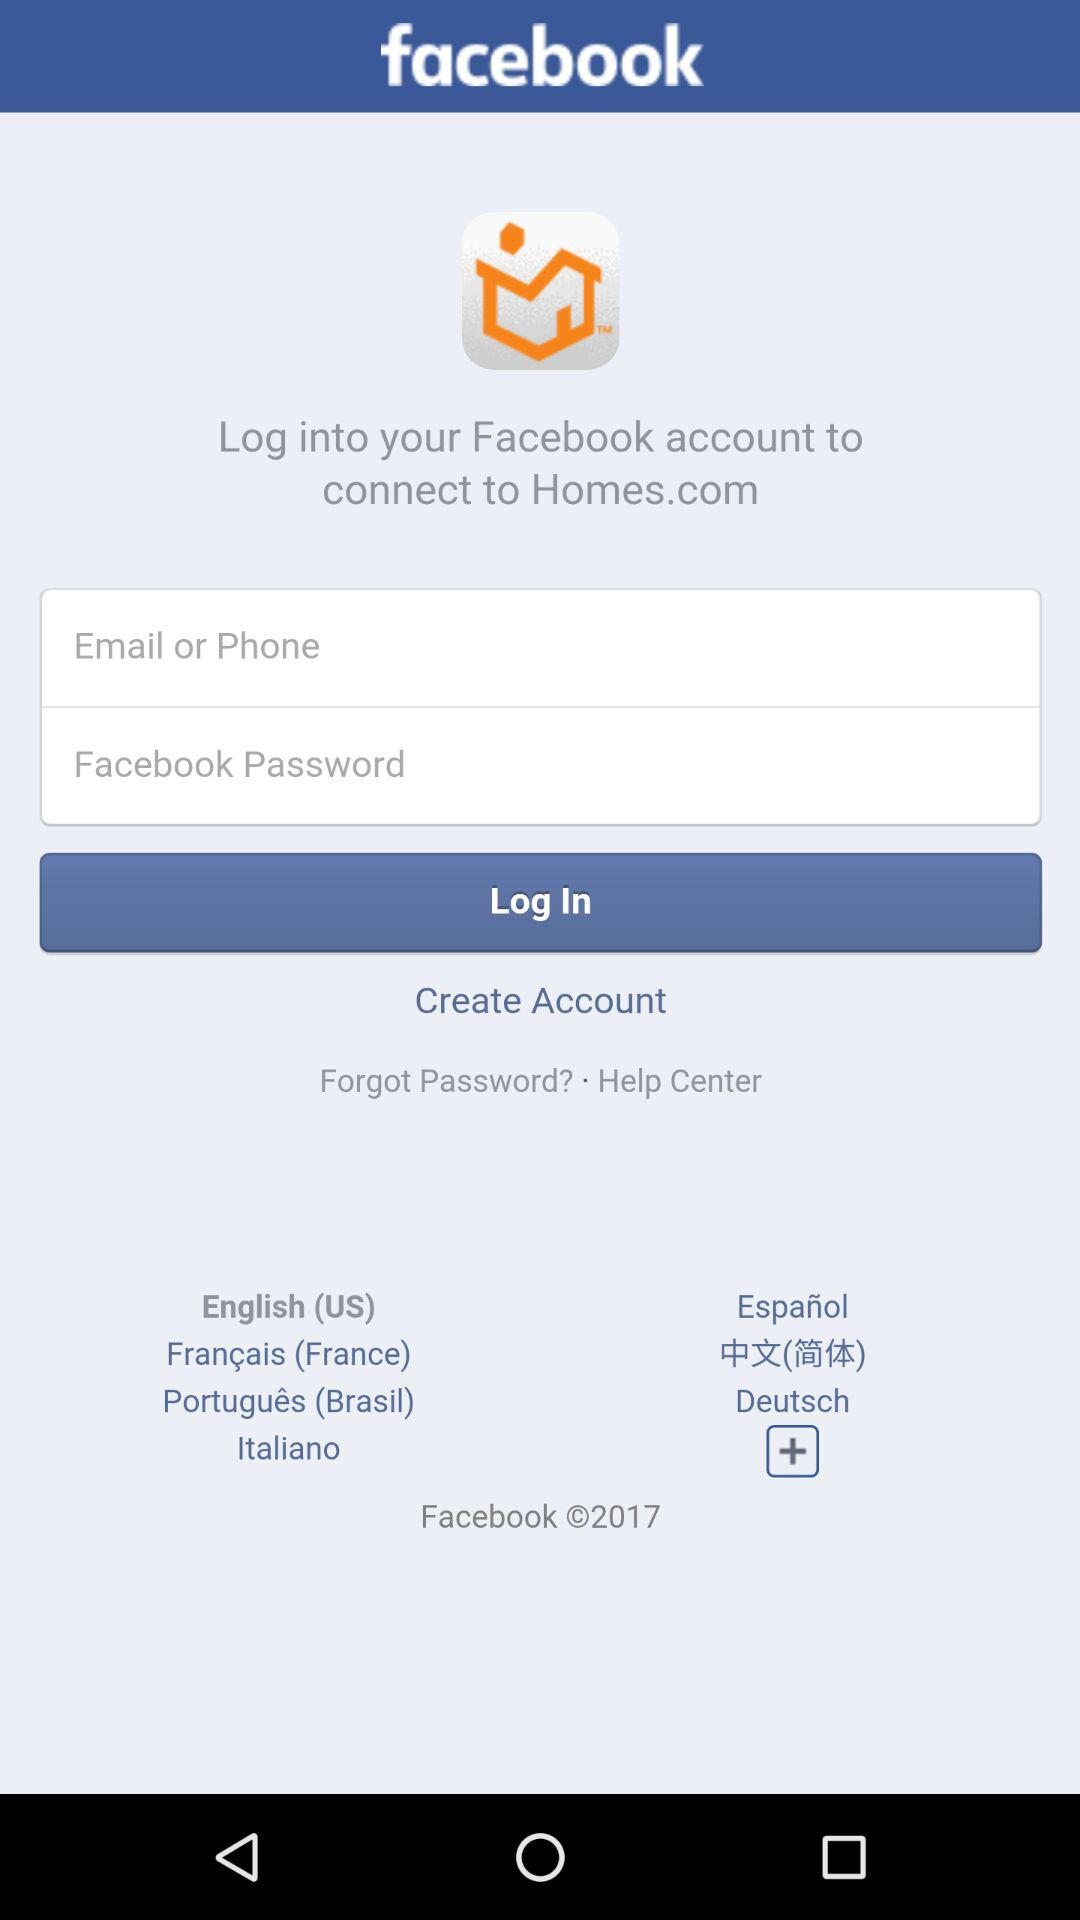Through which application do we log in to connect to "Homes.com"? You can log in through "facebook". 